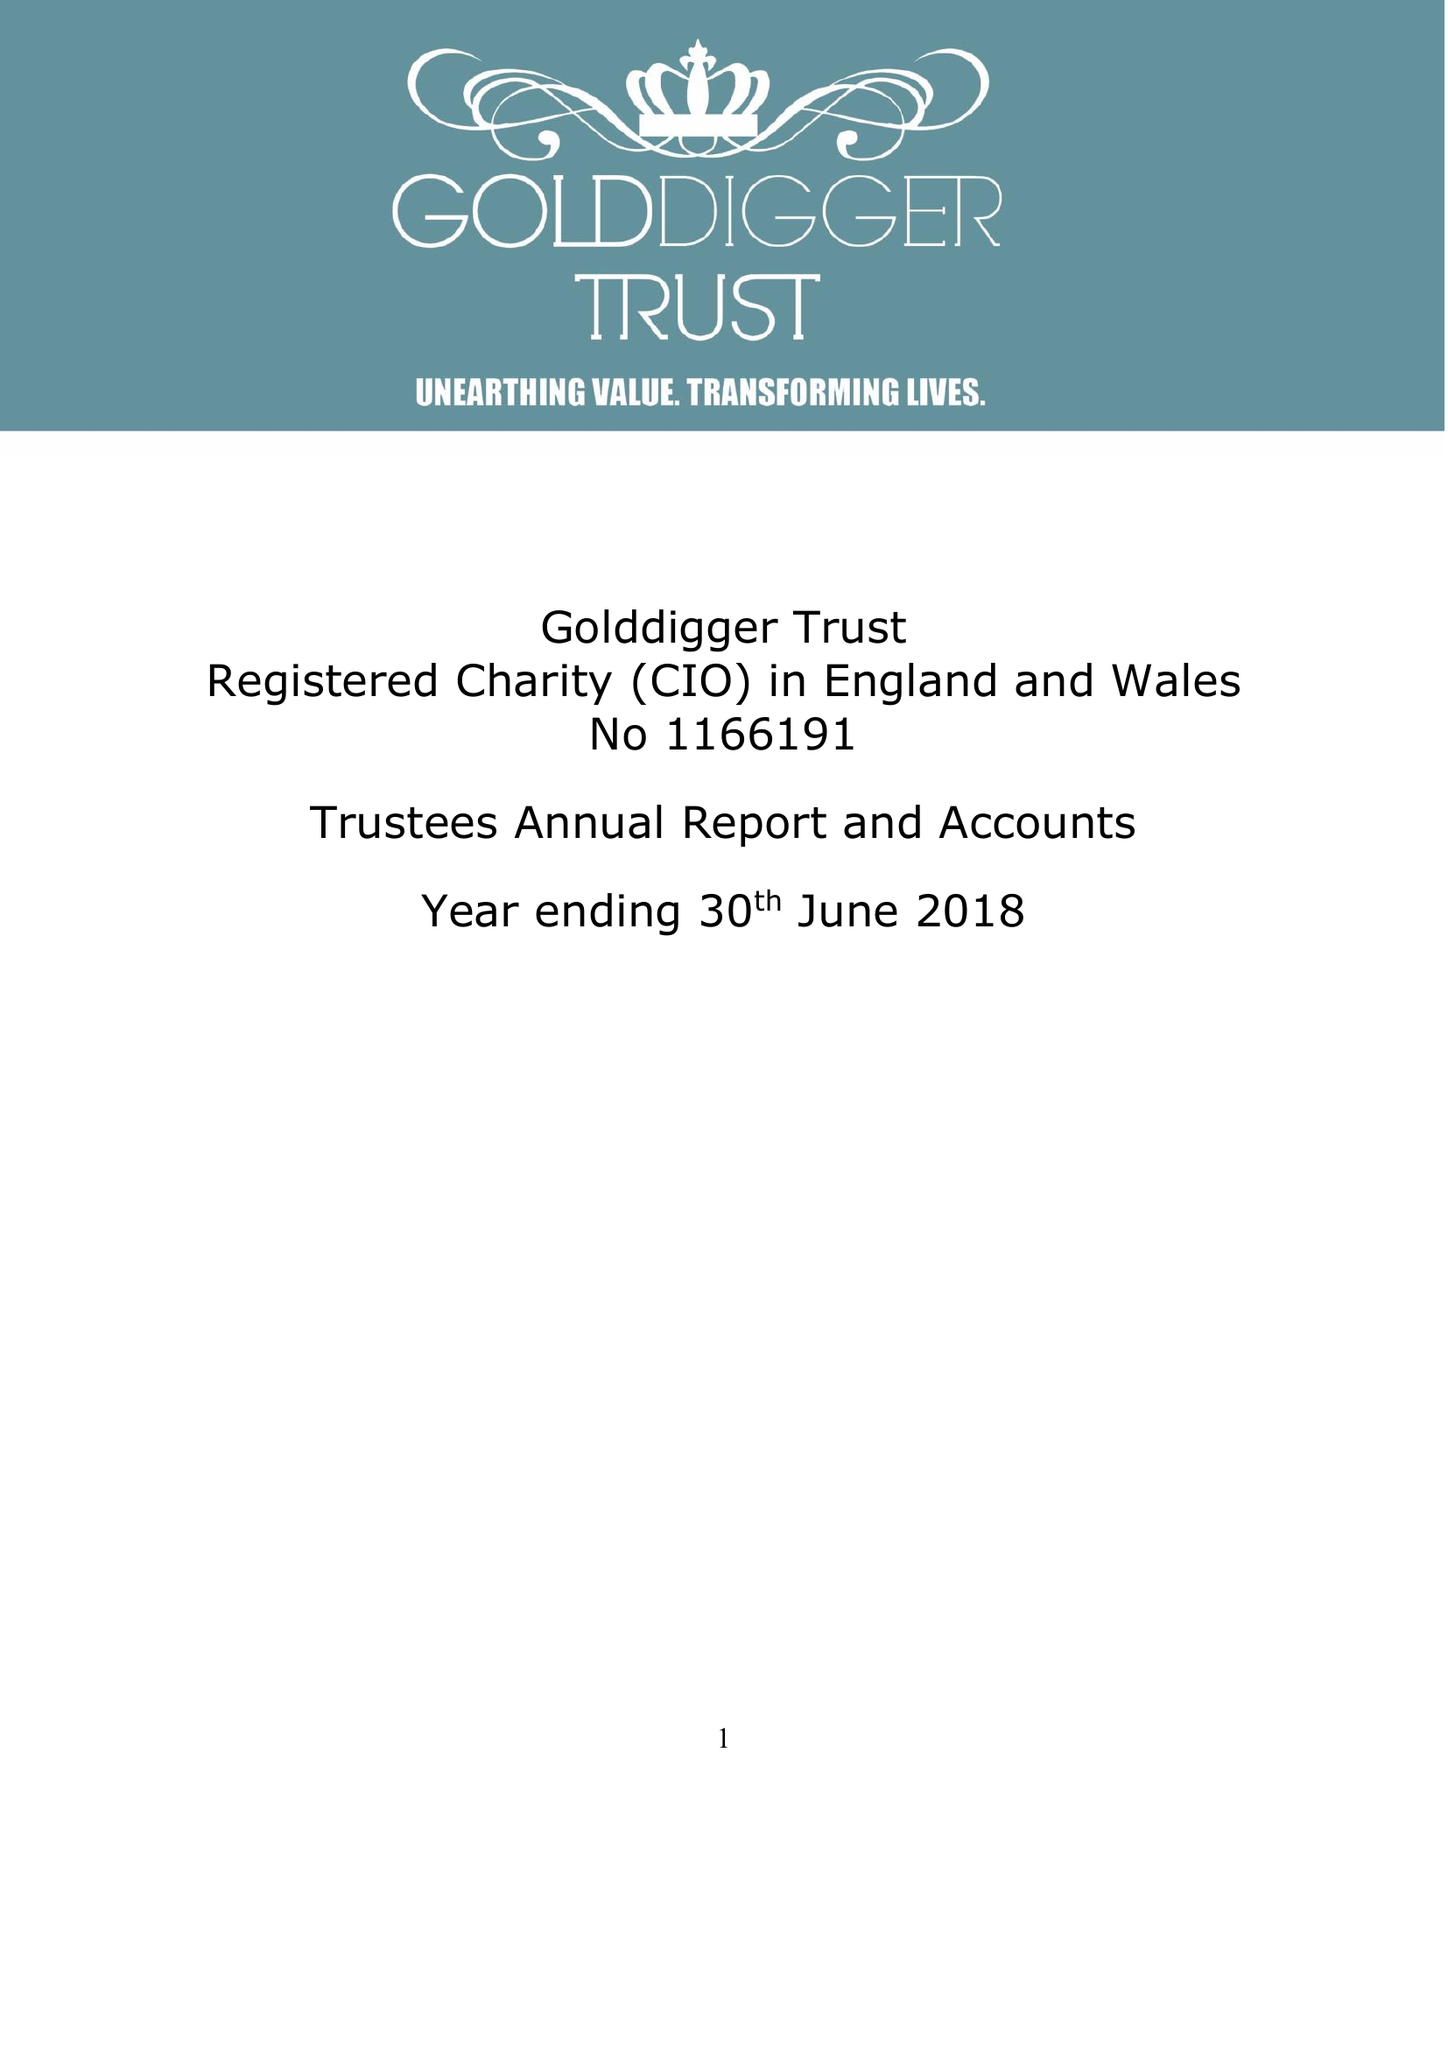What is the value for the report_date?
Answer the question using a single word or phrase. 2018-06-30 